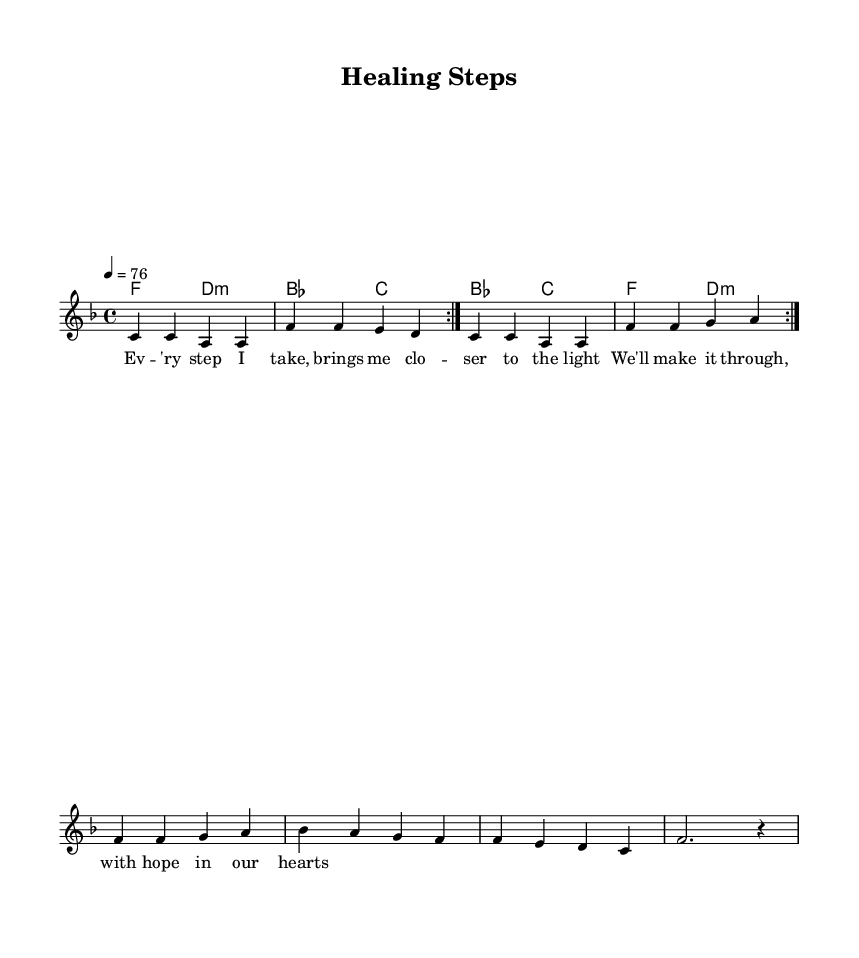What is the key signature of this music? The key signature is F major, which has one flat (B flat). This can be determined by looking at the key signature symbol at the beginning of the music sheet.
Answer: F major What is the time signature of this music? The time signature is 4/4, indicated at the beginning of the music sheet. This shows that there are four beats per measure and the quarter note gets one beat.
Answer: 4/4 What is the tempo marking for this piece? The tempo marking is 76 beats per minute, as shown in the tempo indication at the beginning of the score. This tells performers how fast to play the piece.
Answer: 76 How many measures are in the repeated section of the melody? The repeated section of the melody contains 8 measures, which can be counted visually in the segment that is marked to repeat.
Answer: 8 measures What is the primary lyrical theme of the song? The primary lyrical theme of the song is hope and perseverance, as deduced from the lyrics which focus on hope bringing closeness to the light and making it through with hearts full of hope.
Answer: Hope and perseverance How does the harmony change in the chorus? The harmony shifts from F and D minor to B flat and C, indicating a progression that supports the uplifting message of the chorus. This progression is crucial in R&B to enhance emotional expression.
Answer: F to D minor to B flat to C What type of chord is used predominantly in the verses? The predominant chord used in the verses is F major, as it appears frequently throughout the melody and harmonies. This is a common chord in R&B music that supports the uplifting and hopeful theme.
Answer: F major 